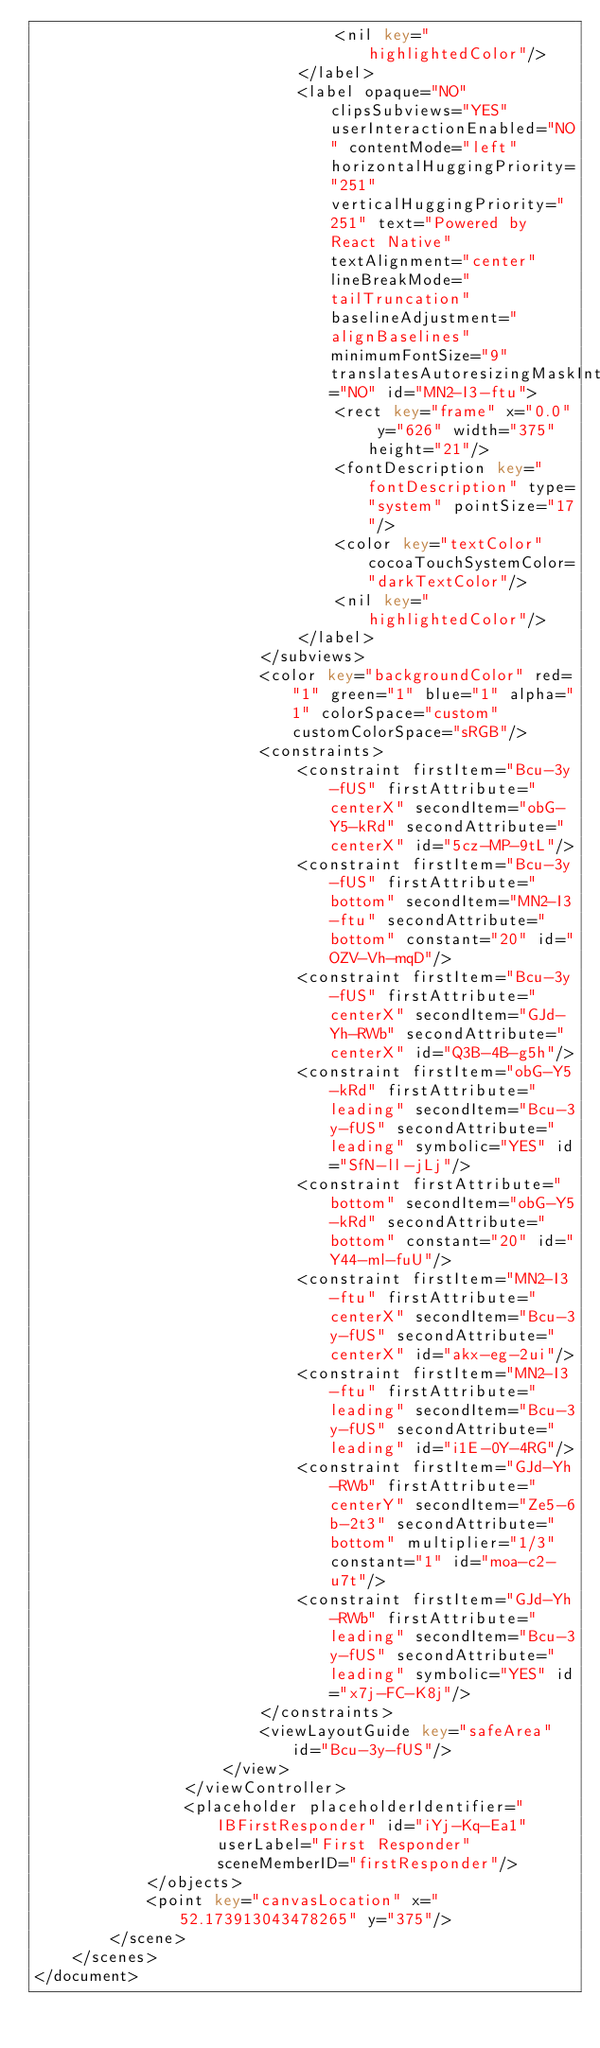<code> <loc_0><loc_0><loc_500><loc_500><_XML_>                                <nil key="highlightedColor"/>
                            </label>
                            <label opaque="NO" clipsSubviews="YES" userInteractionEnabled="NO" contentMode="left" horizontalHuggingPriority="251" verticalHuggingPriority="251" text="Powered by React Native" textAlignment="center" lineBreakMode="tailTruncation" baselineAdjustment="alignBaselines" minimumFontSize="9" translatesAutoresizingMaskIntoConstraints="NO" id="MN2-I3-ftu">
                                <rect key="frame" x="0.0" y="626" width="375" height="21"/>
                                <fontDescription key="fontDescription" type="system" pointSize="17"/>
                                <color key="textColor" cocoaTouchSystemColor="darkTextColor"/>
                                <nil key="highlightedColor"/>
                            </label>
                        </subviews>
                        <color key="backgroundColor" red="1" green="1" blue="1" alpha="1" colorSpace="custom" customColorSpace="sRGB"/>
                        <constraints>
                            <constraint firstItem="Bcu-3y-fUS" firstAttribute="centerX" secondItem="obG-Y5-kRd" secondAttribute="centerX" id="5cz-MP-9tL"/>
                            <constraint firstItem="Bcu-3y-fUS" firstAttribute="bottom" secondItem="MN2-I3-ftu" secondAttribute="bottom" constant="20" id="OZV-Vh-mqD"/>
                            <constraint firstItem="Bcu-3y-fUS" firstAttribute="centerX" secondItem="GJd-Yh-RWb" secondAttribute="centerX" id="Q3B-4B-g5h"/>
                            <constraint firstItem="obG-Y5-kRd" firstAttribute="leading" secondItem="Bcu-3y-fUS" secondAttribute="leading" symbolic="YES" id="SfN-ll-jLj"/>
                            <constraint firstAttribute="bottom" secondItem="obG-Y5-kRd" secondAttribute="bottom" constant="20" id="Y44-ml-fuU"/>
                            <constraint firstItem="MN2-I3-ftu" firstAttribute="centerX" secondItem="Bcu-3y-fUS" secondAttribute="centerX" id="akx-eg-2ui"/>
                            <constraint firstItem="MN2-I3-ftu" firstAttribute="leading" secondItem="Bcu-3y-fUS" secondAttribute="leading" id="i1E-0Y-4RG"/>
                            <constraint firstItem="GJd-Yh-RWb" firstAttribute="centerY" secondItem="Ze5-6b-2t3" secondAttribute="bottom" multiplier="1/3" constant="1" id="moa-c2-u7t"/>
                            <constraint firstItem="GJd-Yh-RWb" firstAttribute="leading" secondItem="Bcu-3y-fUS" secondAttribute="leading" symbolic="YES" id="x7j-FC-K8j"/>
                        </constraints>
                        <viewLayoutGuide key="safeArea" id="Bcu-3y-fUS"/>
                    </view>
                </viewController>
                <placeholder placeholderIdentifier="IBFirstResponder" id="iYj-Kq-Ea1" userLabel="First Responder" sceneMemberID="firstResponder"/>
            </objects>
            <point key="canvasLocation" x="52.173913043478265" y="375"/>
        </scene>
    </scenes>
</document>
</code> 